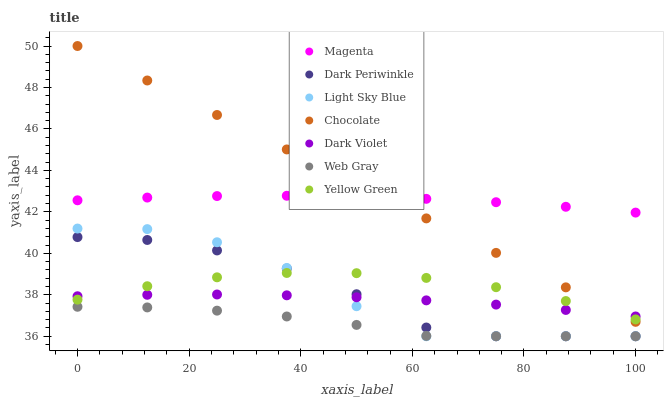Does Web Gray have the minimum area under the curve?
Answer yes or no. Yes. Does Chocolate have the maximum area under the curve?
Answer yes or no. Yes. Does Yellow Green have the minimum area under the curve?
Answer yes or no. No. Does Yellow Green have the maximum area under the curve?
Answer yes or no. No. Is Chocolate the smoothest?
Answer yes or no. Yes. Is Light Sky Blue the roughest?
Answer yes or no. Yes. Is Yellow Green the smoothest?
Answer yes or no. No. Is Yellow Green the roughest?
Answer yes or no. No. Does Web Gray have the lowest value?
Answer yes or no. Yes. Does Yellow Green have the lowest value?
Answer yes or no. No. Does Chocolate have the highest value?
Answer yes or no. Yes. Does Yellow Green have the highest value?
Answer yes or no. No. Is Light Sky Blue less than Chocolate?
Answer yes or no. Yes. Is Magenta greater than Dark Periwinkle?
Answer yes or no. Yes. Does Yellow Green intersect Dark Violet?
Answer yes or no. Yes. Is Yellow Green less than Dark Violet?
Answer yes or no. No. Is Yellow Green greater than Dark Violet?
Answer yes or no. No. Does Light Sky Blue intersect Chocolate?
Answer yes or no. No. 